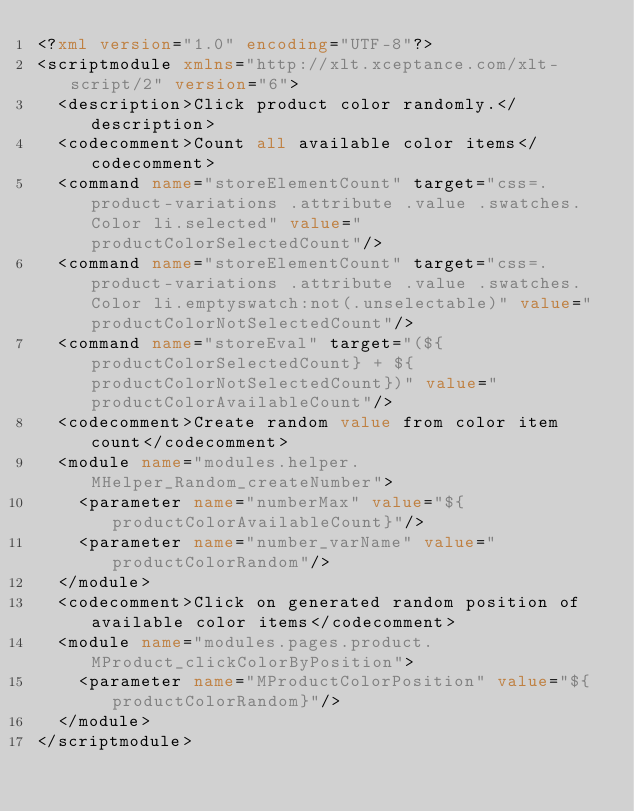Convert code to text. <code><loc_0><loc_0><loc_500><loc_500><_XML_><?xml version="1.0" encoding="UTF-8"?>
<scriptmodule xmlns="http://xlt.xceptance.com/xlt-script/2" version="6">
  <description>Click product color randomly.</description>
  <codecomment>Count all available color items</codecomment>
  <command name="storeElementCount" target="css=.product-variations .attribute .value .swatches.Color li.selected" value="productColorSelectedCount"/>
  <command name="storeElementCount" target="css=.product-variations .attribute .value .swatches.Color li.emptyswatch:not(.unselectable)" value="productColorNotSelectedCount"/>
  <command name="storeEval" target="(${productColorSelectedCount} + ${productColorNotSelectedCount})" value="productColorAvailableCount"/>
  <codecomment>Create random value from color item count</codecomment>
  <module name="modules.helper.MHelper_Random_createNumber">
    <parameter name="numberMax" value="${productColorAvailableCount}"/>
    <parameter name="number_varName" value="productColorRandom"/>
  </module>
  <codecomment>Click on generated random position of available color items</codecomment>
  <module name="modules.pages.product.MProduct_clickColorByPosition">
    <parameter name="MProductColorPosition" value="${productColorRandom}"/>
  </module>
</scriptmodule></code> 